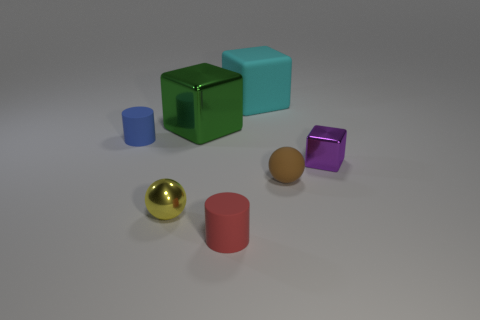Subtract all red cubes. Subtract all gray cylinders. How many cubes are left? 3 Add 1 metallic objects. How many objects exist? 8 Subtract all blocks. How many objects are left? 4 Add 3 brown matte balls. How many brown matte balls exist? 4 Subtract 0 green cylinders. How many objects are left? 7 Subtract all green objects. Subtract all red objects. How many objects are left? 5 Add 2 red matte cylinders. How many red matte cylinders are left? 3 